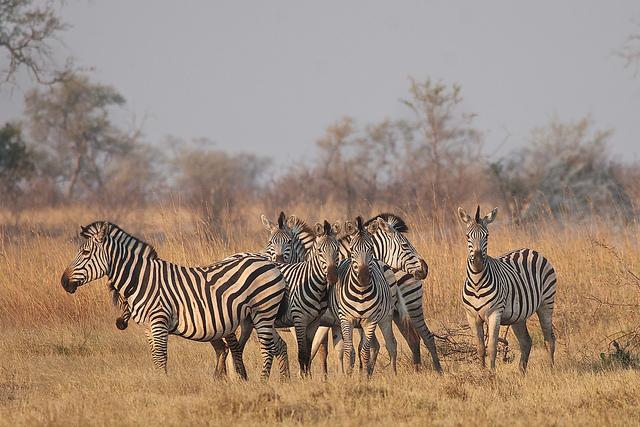How many kinds of animals are clearly visible?
Give a very brief answer. 1. Are they in the desert?
Keep it brief. No. Are zebras peaceful animals?
Write a very short answer. Yes. How many are facing the camera?
Short answer required. 4. Do you see shrubbery and trees?
Short answer required. Yes. How many zebras are facing the camera?
Quick response, please. 4. How many zebras are there?
Quick response, please. 7. Are these zebra's nervous about a predator?
Be succinct. No. Is it getting dark?
Answer briefly. No. 